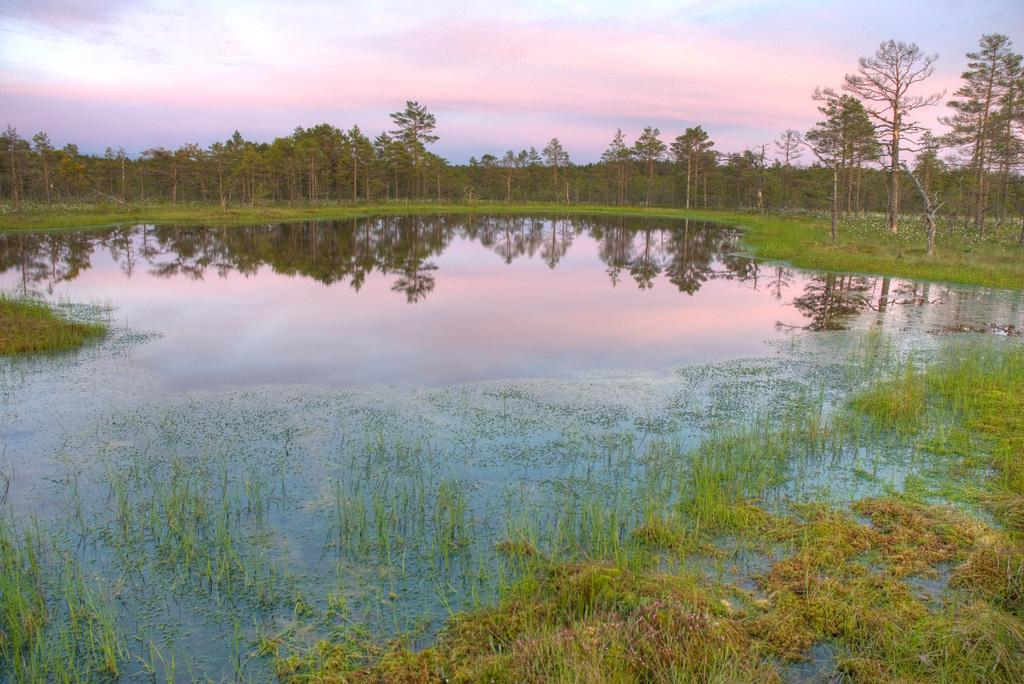What can be seen in the sky in the image? The sky is visible in the image, and there are clouds in the sky. What type of vegetation is present in the image? There are trees and grass in the image. What body of water is visible in the image? There is a lake in the image. What type of cabbage is being harvested by the slave in the image? There is no cabbage or slave present in the image. Can you hear the sound of the lake in the image? The image is a still picture, so there is no sound present. 